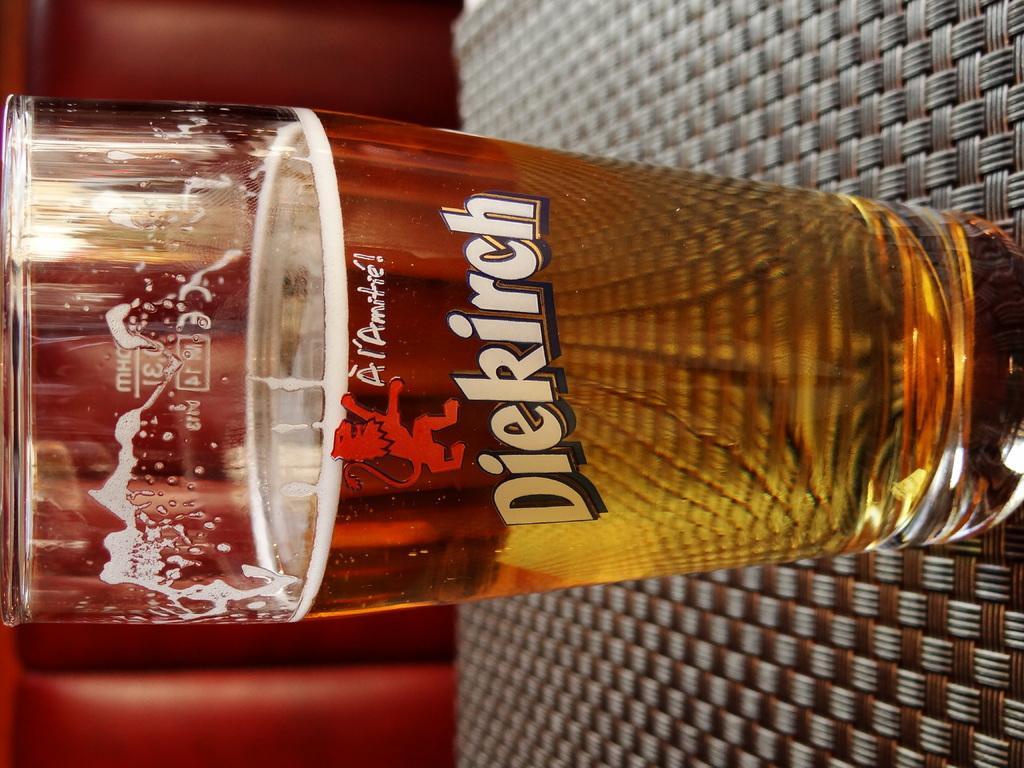How would you summarize this image in a sentence or two? In this image, we can see a glass with liquid and foam. This glass is placed on the surface. Background we can see red color. 